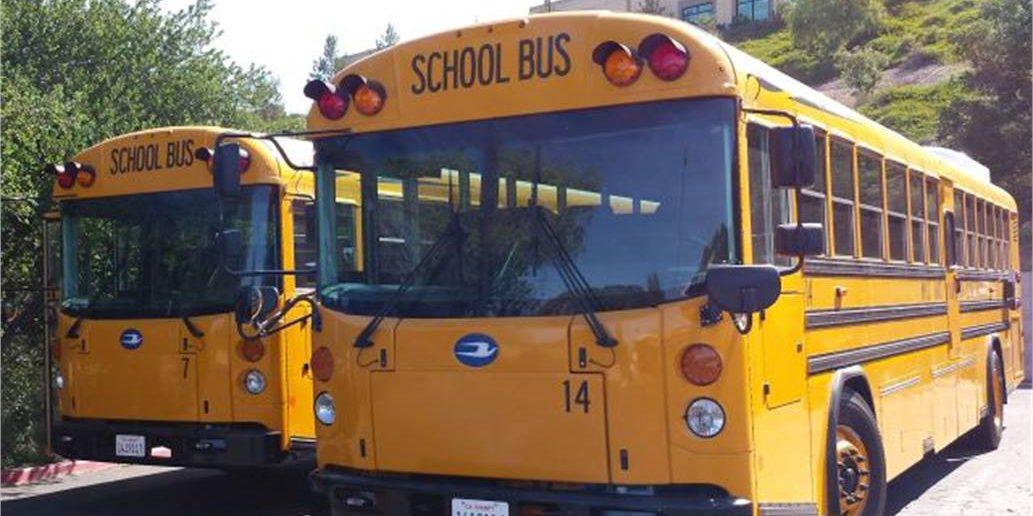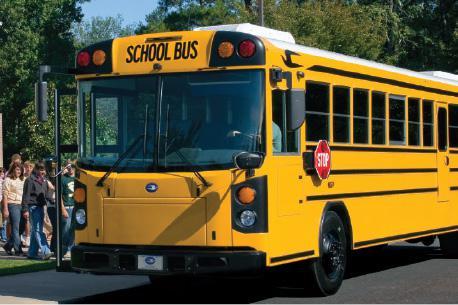The first image is the image on the left, the second image is the image on the right. Considering the images on both sides, is "The school buses in both pictures are facing left." valid? Answer yes or no. Yes. The first image is the image on the left, the second image is the image on the right. For the images shown, is this caption "One of the images features two school buses beside each other and the other image shows a single school bus." true? Answer yes or no. Yes. 